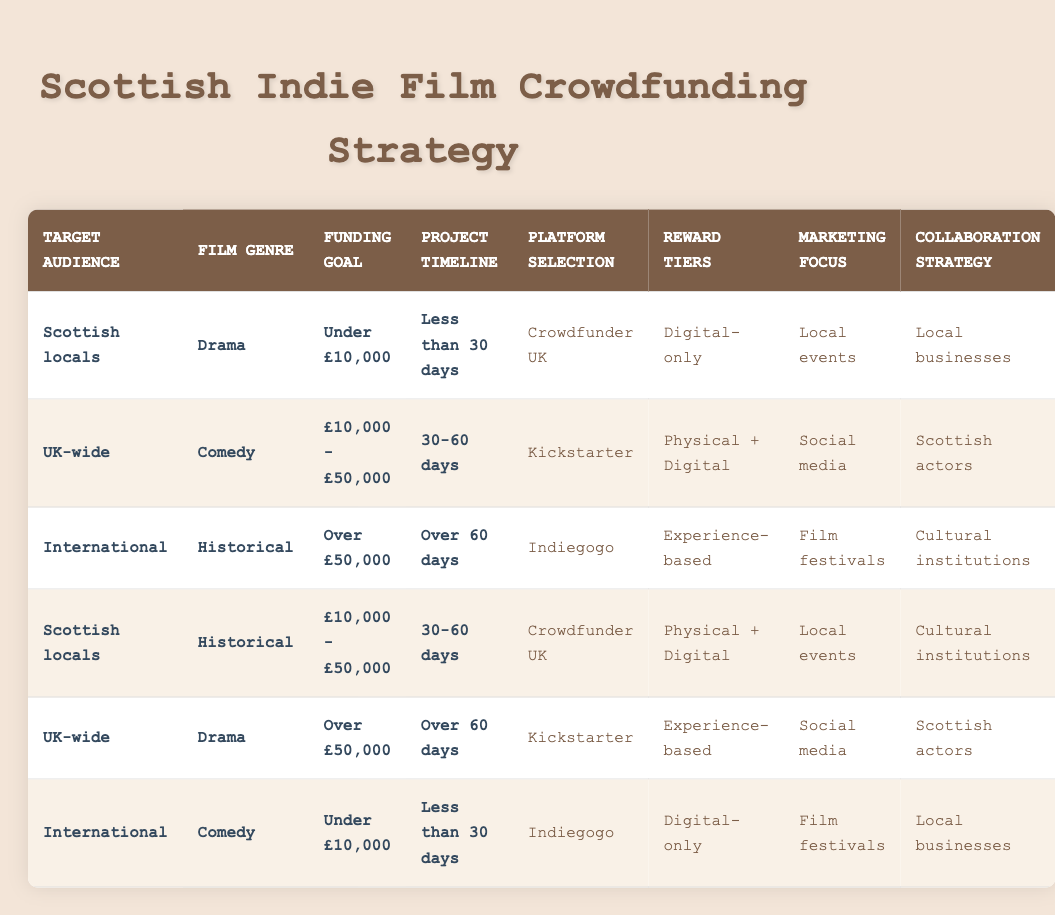What platform is recommended for a Scottish drama film with a funding goal under £10,000 and a project timeline of less than 30 days? By looking at the conditions of the table, the row that matches these criteria—Scottish locals, Drama, Under £10,000, Less than 30 days—shows that the recommended platform is Crowdfunder UK.
Answer: Crowdfunder UK What type of reward tiers is suggested for an international historical film that aims to raise over £50,000 over a period of more than 60 days? The relevant row for this scenario is "International," "Historical," "Over £50,000," "Over 60 days," which indicates that the suggested reward tier is experience-based.
Answer: Experience-based Are local events a marketing focus for any campaign targeting Scottish locals? Reviewing the table, there are two instances where local events are mentioned in the marketing focus for Scottish locals. This makes the statement true.
Answer: Yes How many different funding goals are listed in the table? The funding goals mentioned in the table are: "Under £10,000," "£10,000 - £50,000," and "Over £50,000." Therefore, there are three distinct funding goals listed.
Answer: 3 Is a physical + digital reward tier associated with a UK-wide comedy film with a funding goal between £10,000 and £50,000? By checking the table for the combination of conditions relating to UK-wide, Comedy, and £10,000 - £50,000, it shows that the associated reward tier is physical + digital.
Answer: Yes What is the marketing focus for the Scottish locals' historical film with a funding goal between £10,000 and £50,000 and a timeline of 30-60 days? Looking at the row that fits the criteria—Scottish locals, Historical, £10,000 - £50,000, 30-60 days—the marketing focus is local events.
Answer: Local events Which collaboration strategy is suggested for a UK-wide drama film with a funding goal exceeding £50,000? The relevant row for this scenario is "UK-wide," "Drama," "Over £50,000," "Over 60 days," showing that Scottish actors are the suggested collaboration strategy.
Answer: Scottish actors What are the total combinations of film genres targeted in this crowdfunding strategy table? The genres listed are Drama, Comedy, and Historical. Thus, there are three different film genres targeted in the crowdfunding strategy table.
Answer: 3 